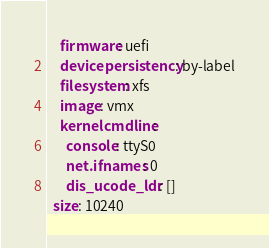Convert code to text. <code><loc_0><loc_0><loc_500><loc_500><_YAML_>    firmware: uefi
    devicepersistency: by-label
    filesystem: xfs
    image: vmx
    kernelcmdline:
      console: ttyS0
      net.ifnames: 0
      dis_ucode_ldr: []
  size: 10240
</code> 